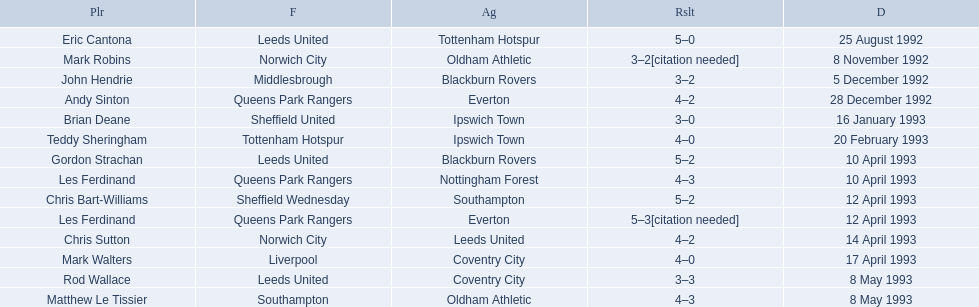What are the results? 5–0, 3–2[citation needed], 3–2, 4–2, 3–0, 4–0, 5–2, 4–3, 5–2, 5–3[citation needed], 4–2, 4–0, 3–3, 4–3. What result did mark robins have? 3–2[citation needed]. What other player had that result? John Hendrie. 